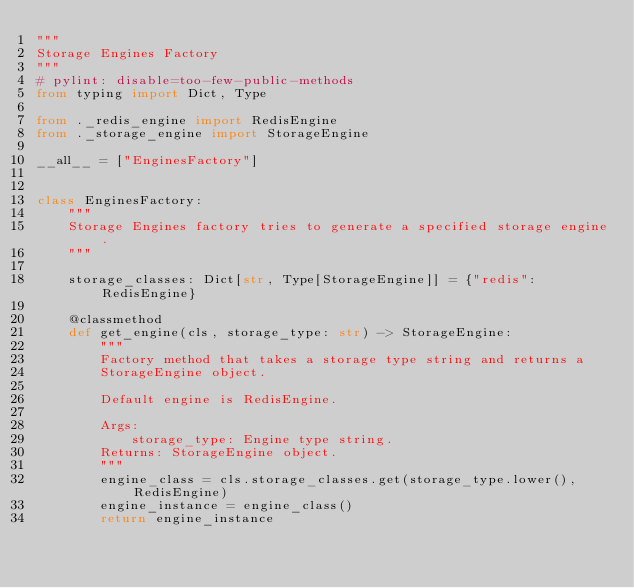<code> <loc_0><loc_0><loc_500><loc_500><_Python_>"""
Storage Engines Factory
"""
# pylint: disable=too-few-public-methods
from typing import Dict, Type

from ._redis_engine import RedisEngine
from ._storage_engine import StorageEngine

__all__ = ["EnginesFactory"]


class EnginesFactory:
    """
    Storage Engines factory tries to generate a specified storage engine.
    """

    storage_classes: Dict[str, Type[StorageEngine]] = {"redis": RedisEngine}

    @classmethod
    def get_engine(cls, storage_type: str) -> StorageEngine:
        """
        Factory method that takes a storage type string and returns a
        StorageEngine object.

        Default engine is RedisEngine.

        Args:
            storage_type: Engine type string.
        Returns: StorageEngine object.
        """
        engine_class = cls.storage_classes.get(storage_type.lower(), RedisEngine)
        engine_instance = engine_class()
        return engine_instance
</code> 